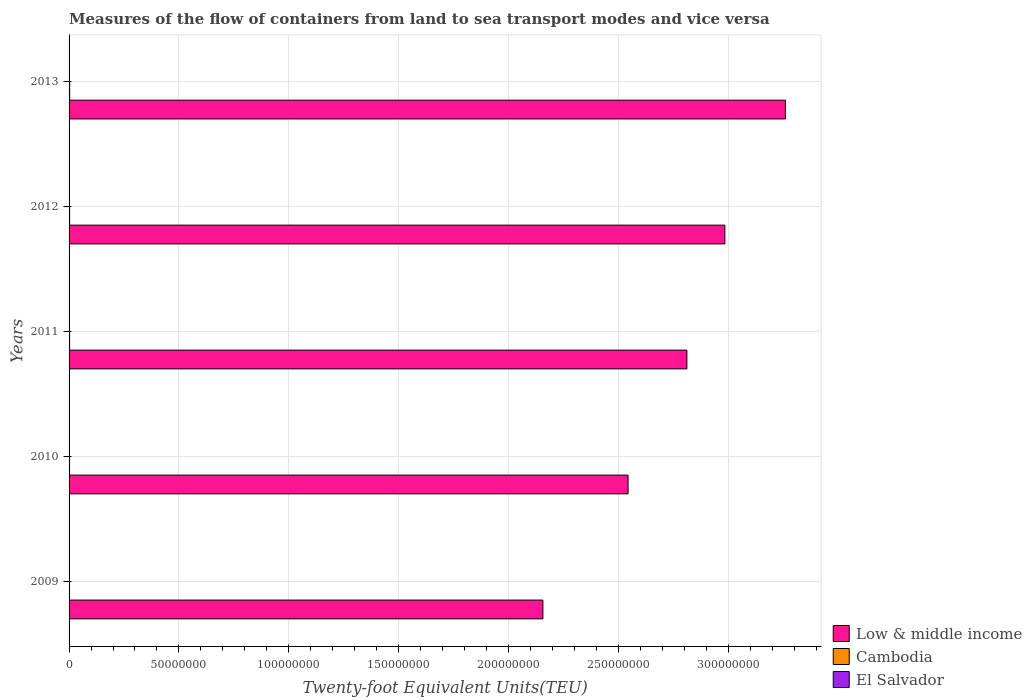How many groups of bars are there?
Your answer should be very brief. 5. What is the label of the 2nd group of bars from the top?
Keep it short and to the point. 2012. In how many cases, is the number of bars for a given year not equal to the number of legend labels?
Provide a short and direct response. 0. What is the container port traffic in El Salvador in 2011?
Your answer should be very brief. 1.61e+05. Across all years, what is the maximum container port traffic in Low & middle income?
Your answer should be compact. 3.26e+08. Across all years, what is the minimum container port traffic in Low & middle income?
Offer a terse response. 2.16e+08. In which year was the container port traffic in El Salvador minimum?
Offer a terse response. 2009. What is the total container port traffic in Low & middle income in the graph?
Your answer should be compact. 1.38e+09. What is the difference between the container port traffic in El Salvador in 2010 and that in 2011?
Your answer should be very brief. -1.54e+04. What is the difference between the container port traffic in Low & middle income in 2010 and the container port traffic in Cambodia in 2012?
Provide a short and direct response. 2.54e+08. What is the average container port traffic in Low & middle income per year?
Offer a terse response. 2.75e+08. In the year 2012, what is the difference between the container port traffic in Low & middle income and container port traffic in Cambodia?
Your response must be concise. 2.98e+08. In how many years, is the container port traffic in Low & middle income greater than 260000000 TEU?
Your answer should be compact. 3. What is the ratio of the container port traffic in Low & middle income in 2011 to that in 2012?
Offer a terse response. 0.94. Is the difference between the container port traffic in Low & middle income in 2012 and 2013 greater than the difference between the container port traffic in Cambodia in 2012 and 2013?
Your response must be concise. No. What is the difference between the highest and the second highest container port traffic in El Salvador?
Offer a terse response. 1.94e+04. What is the difference between the highest and the lowest container port traffic in El Salvador?
Your answer should be compact. 5.42e+04. What does the 2nd bar from the top in 2011 represents?
Provide a short and direct response. Cambodia. What does the 3rd bar from the bottom in 2012 represents?
Ensure brevity in your answer.  El Salvador. How many bars are there?
Your answer should be very brief. 15. How many years are there in the graph?
Give a very brief answer. 5. Where does the legend appear in the graph?
Offer a terse response. Bottom right. How many legend labels are there?
Offer a very short reply. 3. How are the legend labels stacked?
Offer a very short reply. Vertical. What is the title of the graph?
Offer a terse response. Measures of the flow of containers from land to sea transport modes and vice versa. What is the label or title of the X-axis?
Provide a succinct answer. Twenty-foot Equivalent Units(TEU). What is the Twenty-foot Equivalent Units(TEU) of Low & middle income in 2009?
Offer a very short reply. 2.16e+08. What is the Twenty-foot Equivalent Units(TEU) of Cambodia in 2009?
Your answer should be compact. 2.08e+05. What is the Twenty-foot Equivalent Units(TEU) in El Salvador in 2009?
Provide a succinct answer. 1.26e+05. What is the Twenty-foot Equivalent Units(TEU) of Low & middle income in 2010?
Offer a very short reply. 2.54e+08. What is the Twenty-foot Equivalent Units(TEU) of Cambodia in 2010?
Offer a terse response. 2.24e+05. What is the Twenty-foot Equivalent Units(TEU) in El Salvador in 2010?
Offer a terse response. 1.46e+05. What is the Twenty-foot Equivalent Units(TEU) in Low & middle income in 2011?
Your answer should be compact. 2.81e+08. What is the Twenty-foot Equivalent Units(TEU) of Cambodia in 2011?
Your answer should be compact. 2.37e+05. What is the Twenty-foot Equivalent Units(TEU) in El Salvador in 2011?
Your response must be concise. 1.61e+05. What is the Twenty-foot Equivalent Units(TEU) of Low & middle income in 2012?
Give a very brief answer. 2.98e+08. What is the Twenty-foot Equivalent Units(TEU) in Cambodia in 2012?
Offer a very short reply. 2.55e+05. What is the Twenty-foot Equivalent Units(TEU) of El Salvador in 2012?
Your response must be concise. 1.61e+05. What is the Twenty-foot Equivalent Units(TEU) of Low & middle income in 2013?
Your answer should be compact. 3.26e+08. What is the Twenty-foot Equivalent Units(TEU) in Cambodia in 2013?
Keep it short and to the point. 2.75e+05. What is the Twenty-foot Equivalent Units(TEU) in El Salvador in 2013?
Give a very brief answer. 1.81e+05. Across all years, what is the maximum Twenty-foot Equivalent Units(TEU) of Low & middle income?
Provide a short and direct response. 3.26e+08. Across all years, what is the maximum Twenty-foot Equivalent Units(TEU) in Cambodia?
Your answer should be compact. 2.75e+05. Across all years, what is the maximum Twenty-foot Equivalent Units(TEU) in El Salvador?
Your answer should be very brief. 1.81e+05. Across all years, what is the minimum Twenty-foot Equivalent Units(TEU) in Low & middle income?
Your answer should be very brief. 2.16e+08. Across all years, what is the minimum Twenty-foot Equivalent Units(TEU) of Cambodia?
Provide a short and direct response. 2.08e+05. Across all years, what is the minimum Twenty-foot Equivalent Units(TEU) in El Salvador?
Offer a very short reply. 1.26e+05. What is the total Twenty-foot Equivalent Units(TEU) in Low & middle income in the graph?
Provide a succinct answer. 1.38e+09. What is the total Twenty-foot Equivalent Units(TEU) of Cambodia in the graph?
Ensure brevity in your answer.  1.20e+06. What is the total Twenty-foot Equivalent Units(TEU) in El Salvador in the graph?
Your answer should be very brief. 7.75e+05. What is the difference between the Twenty-foot Equivalent Units(TEU) in Low & middle income in 2009 and that in 2010?
Provide a succinct answer. -3.88e+07. What is the difference between the Twenty-foot Equivalent Units(TEU) in Cambodia in 2009 and that in 2010?
Your answer should be very brief. -1.66e+04. What is the difference between the Twenty-foot Equivalent Units(TEU) in El Salvador in 2009 and that in 2010?
Keep it short and to the point. -1.94e+04. What is the difference between the Twenty-foot Equivalent Units(TEU) in Low & middle income in 2009 and that in 2011?
Ensure brevity in your answer.  -6.55e+07. What is the difference between the Twenty-foot Equivalent Units(TEU) of Cambodia in 2009 and that in 2011?
Your answer should be compact. -2.94e+04. What is the difference between the Twenty-foot Equivalent Units(TEU) of El Salvador in 2009 and that in 2011?
Make the answer very short. -3.48e+04. What is the difference between the Twenty-foot Equivalent Units(TEU) in Low & middle income in 2009 and that in 2012?
Your response must be concise. -8.28e+07. What is the difference between the Twenty-foot Equivalent Units(TEU) in Cambodia in 2009 and that in 2012?
Keep it short and to the point. -4.72e+04. What is the difference between the Twenty-foot Equivalent Units(TEU) in El Salvador in 2009 and that in 2012?
Ensure brevity in your answer.  -3.46e+04. What is the difference between the Twenty-foot Equivalent Units(TEU) in Low & middle income in 2009 and that in 2013?
Your response must be concise. -1.10e+08. What is the difference between the Twenty-foot Equivalent Units(TEU) of Cambodia in 2009 and that in 2013?
Offer a very short reply. -6.73e+04. What is the difference between the Twenty-foot Equivalent Units(TEU) in El Salvador in 2009 and that in 2013?
Your response must be concise. -5.42e+04. What is the difference between the Twenty-foot Equivalent Units(TEU) of Low & middle income in 2010 and that in 2011?
Give a very brief answer. -2.68e+07. What is the difference between the Twenty-foot Equivalent Units(TEU) in Cambodia in 2010 and that in 2011?
Ensure brevity in your answer.  -1.28e+04. What is the difference between the Twenty-foot Equivalent Units(TEU) of El Salvador in 2010 and that in 2011?
Give a very brief answer. -1.54e+04. What is the difference between the Twenty-foot Equivalent Units(TEU) of Low & middle income in 2010 and that in 2012?
Keep it short and to the point. -4.41e+07. What is the difference between the Twenty-foot Equivalent Units(TEU) of Cambodia in 2010 and that in 2012?
Your answer should be compact. -3.06e+04. What is the difference between the Twenty-foot Equivalent Units(TEU) of El Salvador in 2010 and that in 2012?
Provide a short and direct response. -1.52e+04. What is the difference between the Twenty-foot Equivalent Units(TEU) in Low & middle income in 2010 and that in 2013?
Provide a succinct answer. -7.16e+07. What is the difference between the Twenty-foot Equivalent Units(TEU) of Cambodia in 2010 and that in 2013?
Keep it short and to the point. -5.07e+04. What is the difference between the Twenty-foot Equivalent Units(TEU) of El Salvador in 2010 and that in 2013?
Give a very brief answer. -3.48e+04. What is the difference between the Twenty-foot Equivalent Units(TEU) of Low & middle income in 2011 and that in 2012?
Keep it short and to the point. -1.73e+07. What is the difference between the Twenty-foot Equivalent Units(TEU) of Cambodia in 2011 and that in 2012?
Provide a short and direct response. -1.78e+04. What is the difference between the Twenty-foot Equivalent Units(TEU) in Low & middle income in 2011 and that in 2013?
Your response must be concise. -4.48e+07. What is the difference between the Twenty-foot Equivalent Units(TEU) in Cambodia in 2011 and that in 2013?
Your answer should be compact. -3.79e+04. What is the difference between the Twenty-foot Equivalent Units(TEU) in El Salvador in 2011 and that in 2013?
Give a very brief answer. -1.94e+04. What is the difference between the Twenty-foot Equivalent Units(TEU) in Low & middle income in 2012 and that in 2013?
Make the answer very short. -2.75e+07. What is the difference between the Twenty-foot Equivalent Units(TEU) of Cambodia in 2012 and that in 2013?
Provide a succinct answer. -2.01e+04. What is the difference between the Twenty-foot Equivalent Units(TEU) in El Salvador in 2012 and that in 2013?
Your answer should be very brief. -1.96e+04. What is the difference between the Twenty-foot Equivalent Units(TEU) in Low & middle income in 2009 and the Twenty-foot Equivalent Units(TEU) in Cambodia in 2010?
Your answer should be compact. 2.15e+08. What is the difference between the Twenty-foot Equivalent Units(TEU) in Low & middle income in 2009 and the Twenty-foot Equivalent Units(TEU) in El Salvador in 2010?
Keep it short and to the point. 2.15e+08. What is the difference between the Twenty-foot Equivalent Units(TEU) in Cambodia in 2009 and the Twenty-foot Equivalent Units(TEU) in El Salvador in 2010?
Make the answer very short. 6.18e+04. What is the difference between the Twenty-foot Equivalent Units(TEU) of Low & middle income in 2009 and the Twenty-foot Equivalent Units(TEU) of Cambodia in 2011?
Provide a short and direct response. 2.15e+08. What is the difference between the Twenty-foot Equivalent Units(TEU) of Low & middle income in 2009 and the Twenty-foot Equivalent Units(TEU) of El Salvador in 2011?
Your answer should be very brief. 2.15e+08. What is the difference between the Twenty-foot Equivalent Units(TEU) in Cambodia in 2009 and the Twenty-foot Equivalent Units(TEU) in El Salvador in 2011?
Ensure brevity in your answer.  4.64e+04. What is the difference between the Twenty-foot Equivalent Units(TEU) in Low & middle income in 2009 and the Twenty-foot Equivalent Units(TEU) in Cambodia in 2012?
Give a very brief answer. 2.15e+08. What is the difference between the Twenty-foot Equivalent Units(TEU) in Low & middle income in 2009 and the Twenty-foot Equivalent Units(TEU) in El Salvador in 2012?
Provide a succinct answer. 2.15e+08. What is the difference between the Twenty-foot Equivalent Units(TEU) in Cambodia in 2009 and the Twenty-foot Equivalent Units(TEU) in El Salvador in 2012?
Offer a terse response. 4.66e+04. What is the difference between the Twenty-foot Equivalent Units(TEU) in Low & middle income in 2009 and the Twenty-foot Equivalent Units(TEU) in Cambodia in 2013?
Keep it short and to the point. 2.15e+08. What is the difference between the Twenty-foot Equivalent Units(TEU) in Low & middle income in 2009 and the Twenty-foot Equivalent Units(TEU) in El Salvador in 2013?
Make the answer very short. 2.15e+08. What is the difference between the Twenty-foot Equivalent Units(TEU) of Cambodia in 2009 and the Twenty-foot Equivalent Units(TEU) of El Salvador in 2013?
Provide a succinct answer. 2.70e+04. What is the difference between the Twenty-foot Equivalent Units(TEU) of Low & middle income in 2010 and the Twenty-foot Equivalent Units(TEU) of Cambodia in 2011?
Offer a terse response. 2.54e+08. What is the difference between the Twenty-foot Equivalent Units(TEU) in Low & middle income in 2010 and the Twenty-foot Equivalent Units(TEU) in El Salvador in 2011?
Provide a short and direct response. 2.54e+08. What is the difference between the Twenty-foot Equivalent Units(TEU) of Cambodia in 2010 and the Twenty-foot Equivalent Units(TEU) of El Salvador in 2011?
Offer a very short reply. 6.30e+04. What is the difference between the Twenty-foot Equivalent Units(TEU) of Low & middle income in 2010 and the Twenty-foot Equivalent Units(TEU) of Cambodia in 2012?
Make the answer very short. 2.54e+08. What is the difference between the Twenty-foot Equivalent Units(TEU) of Low & middle income in 2010 and the Twenty-foot Equivalent Units(TEU) of El Salvador in 2012?
Your answer should be very brief. 2.54e+08. What is the difference between the Twenty-foot Equivalent Units(TEU) in Cambodia in 2010 and the Twenty-foot Equivalent Units(TEU) in El Salvador in 2012?
Keep it short and to the point. 6.32e+04. What is the difference between the Twenty-foot Equivalent Units(TEU) in Low & middle income in 2010 and the Twenty-foot Equivalent Units(TEU) in Cambodia in 2013?
Offer a terse response. 2.54e+08. What is the difference between the Twenty-foot Equivalent Units(TEU) of Low & middle income in 2010 and the Twenty-foot Equivalent Units(TEU) of El Salvador in 2013?
Provide a short and direct response. 2.54e+08. What is the difference between the Twenty-foot Equivalent Units(TEU) in Cambodia in 2010 and the Twenty-foot Equivalent Units(TEU) in El Salvador in 2013?
Your response must be concise. 4.36e+04. What is the difference between the Twenty-foot Equivalent Units(TEU) of Low & middle income in 2011 and the Twenty-foot Equivalent Units(TEU) of Cambodia in 2012?
Give a very brief answer. 2.81e+08. What is the difference between the Twenty-foot Equivalent Units(TEU) of Low & middle income in 2011 and the Twenty-foot Equivalent Units(TEU) of El Salvador in 2012?
Keep it short and to the point. 2.81e+08. What is the difference between the Twenty-foot Equivalent Units(TEU) of Cambodia in 2011 and the Twenty-foot Equivalent Units(TEU) of El Salvador in 2012?
Ensure brevity in your answer.  7.60e+04. What is the difference between the Twenty-foot Equivalent Units(TEU) in Low & middle income in 2011 and the Twenty-foot Equivalent Units(TEU) in Cambodia in 2013?
Your response must be concise. 2.81e+08. What is the difference between the Twenty-foot Equivalent Units(TEU) in Low & middle income in 2011 and the Twenty-foot Equivalent Units(TEU) in El Salvador in 2013?
Give a very brief answer. 2.81e+08. What is the difference between the Twenty-foot Equivalent Units(TEU) in Cambodia in 2011 and the Twenty-foot Equivalent Units(TEU) in El Salvador in 2013?
Ensure brevity in your answer.  5.64e+04. What is the difference between the Twenty-foot Equivalent Units(TEU) of Low & middle income in 2012 and the Twenty-foot Equivalent Units(TEU) of Cambodia in 2013?
Give a very brief answer. 2.98e+08. What is the difference between the Twenty-foot Equivalent Units(TEU) of Low & middle income in 2012 and the Twenty-foot Equivalent Units(TEU) of El Salvador in 2013?
Ensure brevity in your answer.  2.98e+08. What is the difference between the Twenty-foot Equivalent Units(TEU) in Cambodia in 2012 and the Twenty-foot Equivalent Units(TEU) in El Salvador in 2013?
Offer a very short reply. 7.42e+04. What is the average Twenty-foot Equivalent Units(TEU) of Low & middle income per year?
Ensure brevity in your answer.  2.75e+08. What is the average Twenty-foot Equivalent Units(TEU) in Cambodia per year?
Give a very brief answer. 2.40e+05. What is the average Twenty-foot Equivalent Units(TEU) in El Salvador per year?
Provide a short and direct response. 1.55e+05. In the year 2009, what is the difference between the Twenty-foot Equivalent Units(TEU) in Low & middle income and Twenty-foot Equivalent Units(TEU) in Cambodia?
Make the answer very short. 2.15e+08. In the year 2009, what is the difference between the Twenty-foot Equivalent Units(TEU) of Low & middle income and Twenty-foot Equivalent Units(TEU) of El Salvador?
Give a very brief answer. 2.16e+08. In the year 2009, what is the difference between the Twenty-foot Equivalent Units(TEU) of Cambodia and Twenty-foot Equivalent Units(TEU) of El Salvador?
Ensure brevity in your answer.  8.12e+04. In the year 2010, what is the difference between the Twenty-foot Equivalent Units(TEU) in Low & middle income and Twenty-foot Equivalent Units(TEU) in Cambodia?
Provide a short and direct response. 2.54e+08. In the year 2010, what is the difference between the Twenty-foot Equivalent Units(TEU) in Low & middle income and Twenty-foot Equivalent Units(TEU) in El Salvador?
Ensure brevity in your answer.  2.54e+08. In the year 2010, what is the difference between the Twenty-foot Equivalent Units(TEU) in Cambodia and Twenty-foot Equivalent Units(TEU) in El Salvador?
Ensure brevity in your answer.  7.84e+04. In the year 2011, what is the difference between the Twenty-foot Equivalent Units(TEU) of Low & middle income and Twenty-foot Equivalent Units(TEU) of Cambodia?
Give a very brief answer. 2.81e+08. In the year 2011, what is the difference between the Twenty-foot Equivalent Units(TEU) in Low & middle income and Twenty-foot Equivalent Units(TEU) in El Salvador?
Make the answer very short. 2.81e+08. In the year 2011, what is the difference between the Twenty-foot Equivalent Units(TEU) of Cambodia and Twenty-foot Equivalent Units(TEU) of El Salvador?
Keep it short and to the point. 7.58e+04. In the year 2012, what is the difference between the Twenty-foot Equivalent Units(TEU) of Low & middle income and Twenty-foot Equivalent Units(TEU) of Cambodia?
Offer a very short reply. 2.98e+08. In the year 2012, what is the difference between the Twenty-foot Equivalent Units(TEU) in Low & middle income and Twenty-foot Equivalent Units(TEU) in El Salvador?
Give a very brief answer. 2.98e+08. In the year 2012, what is the difference between the Twenty-foot Equivalent Units(TEU) in Cambodia and Twenty-foot Equivalent Units(TEU) in El Salvador?
Offer a very short reply. 9.38e+04. In the year 2013, what is the difference between the Twenty-foot Equivalent Units(TEU) of Low & middle income and Twenty-foot Equivalent Units(TEU) of Cambodia?
Your answer should be compact. 3.26e+08. In the year 2013, what is the difference between the Twenty-foot Equivalent Units(TEU) in Low & middle income and Twenty-foot Equivalent Units(TEU) in El Salvador?
Offer a terse response. 3.26e+08. In the year 2013, what is the difference between the Twenty-foot Equivalent Units(TEU) in Cambodia and Twenty-foot Equivalent Units(TEU) in El Salvador?
Offer a very short reply. 9.43e+04. What is the ratio of the Twenty-foot Equivalent Units(TEU) of Low & middle income in 2009 to that in 2010?
Your response must be concise. 0.85. What is the ratio of the Twenty-foot Equivalent Units(TEU) in Cambodia in 2009 to that in 2010?
Offer a very short reply. 0.93. What is the ratio of the Twenty-foot Equivalent Units(TEU) in El Salvador in 2009 to that in 2010?
Ensure brevity in your answer.  0.87. What is the ratio of the Twenty-foot Equivalent Units(TEU) in Low & middle income in 2009 to that in 2011?
Ensure brevity in your answer.  0.77. What is the ratio of the Twenty-foot Equivalent Units(TEU) of Cambodia in 2009 to that in 2011?
Offer a terse response. 0.88. What is the ratio of the Twenty-foot Equivalent Units(TEU) of El Salvador in 2009 to that in 2011?
Your answer should be compact. 0.78. What is the ratio of the Twenty-foot Equivalent Units(TEU) in Low & middle income in 2009 to that in 2012?
Offer a very short reply. 0.72. What is the ratio of the Twenty-foot Equivalent Units(TEU) of Cambodia in 2009 to that in 2012?
Give a very brief answer. 0.81. What is the ratio of the Twenty-foot Equivalent Units(TEU) in El Salvador in 2009 to that in 2012?
Keep it short and to the point. 0.78. What is the ratio of the Twenty-foot Equivalent Units(TEU) in Low & middle income in 2009 to that in 2013?
Your answer should be compact. 0.66. What is the ratio of the Twenty-foot Equivalent Units(TEU) of Cambodia in 2009 to that in 2013?
Give a very brief answer. 0.76. What is the ratio of the Twenty-foot Equivalent Units(TEU) in El Salvador in 2009 to that in 2013?
Make the answer very short. 0.7. What is the ratio of the Twenty-foot Equivalent Units(TEU) in Low & middle income in 2010 to that in 2011?
Provide a succinct answer. 0.9. What is the ratio of the Twenty-foot Equivalent Units(TEU) in Cambodia in 2010 to that in 2011?
Offer a very short reply. 0.95. What is the ratio of the Twenty-foot Equivalent Units(TEU) in El Salvador in 2010 to that in 2011?
Your answer should be compact. 0.9. What is the ratio of the Twenty-foot Equivalent Units(TEU) in Low & middle income in 2010 to that in 2012?
Make the answer very short. 0.85. What is the ratio of the Twenty-foot Equivalent Units(TEU) of Cambodia in 2010 to that in 2012?
Your answer should be compact. 0.88. What is the ratio of the Twenty-foot Equivalent Units(TEU) in El Salvador in 2010 to that in 2012?
Give a very brief answer. 0.91. What is the ratio of the Twenty-foot Equivalent Units(TEU) of Low & middle income in 2010 to that in 2013?
Make the answer very short. 0.78. What is the ratio of the Twenty-foot Equivalent Units(TEU) of Cambodia in 2010 to that in 2013?
Offer a terse response. 0.82. What is the ratio of the Twenty-foot Equivalent Units(TEU) in El Salvador in 2010 to that in 2013?
Offer a very short reply. 0.81. What is the ratio of the Twenty-foot Equivalent Units(TEU) in Low & middle income in 2011 to that in 2012?
Your answer should be compact. 0.94. What is the ratio of the Twenty-foot Equivalent Units(TEU) of Cambodia in 2011 to that in 2012?
Ensure brevity in your answer.  0.93. What is the ratio of the Twenty-foot Equivalent Units(TEU) in El Salvador in 2011 to that in 2012?
Offer a terse response. 1. What is the ratio of the Twenty-foot Equivalent Units(TEU) of Low & middle income in 2011 to that in 2013?
Give a very brief answer. 0.86. What is the ratio of the Twenty-foot Equivalent Units(TEU) in Cambodia in 2011 to that in 2013?
Your response must be concise. 0.86. What is the ratio of the Twenty-foot Equivalent Units(TEU) in El Salvador in 2011 to that in 2013?
Your response must be concise. 0.89. What is the ratio of the Twenty-foot Equivalent Units(TEU) of Low & middle income in 2012 to that in 2013?
Your response must be concise. 0.92. What is the ratio of the Twenty-foot Equivalent Units(TEU) of Cambodia in 2012 to that in 2013?
Your answer should be very brief. 0.93. What is the ratio of the Twenty-foot Equivalent Units(TEU) of El Salvador in 2012 to that in 2013?
Give a very brief answer. 0.89. What is the difference between the highest and the second highest Twenty-foot Equivalent Units(TEU) in Low & middle income?
Ensure brevity in your answer.  2.75e+07. What is the difference between the highest and the second highest Twenty-foot Equivalent Units(TEU) of Cambodia?
Offer a very short reply. 2.01e+04. What is the difference between the highest and the second highest Twenty-foot Equivalent Units(TEU) in El Salvador?
Your answer should be very brief. 1.94e+04. What is the difference between the highest and the lowest Twenty-foot Equivalent Units(TEU) of Low & middle income?
Make the answer very short. 1.10e+08. What is the difference between the highest and the lowest Twenty-foot Equivalent Units(TEU) in Cambodia?
Provide a succinct answer. 6.73e+04. What is the difference between the highest and the lowest Twenty-foot Equivalent Units(TEU) of El Salvador?
Provide a short and direct response. 5.42e+04. 